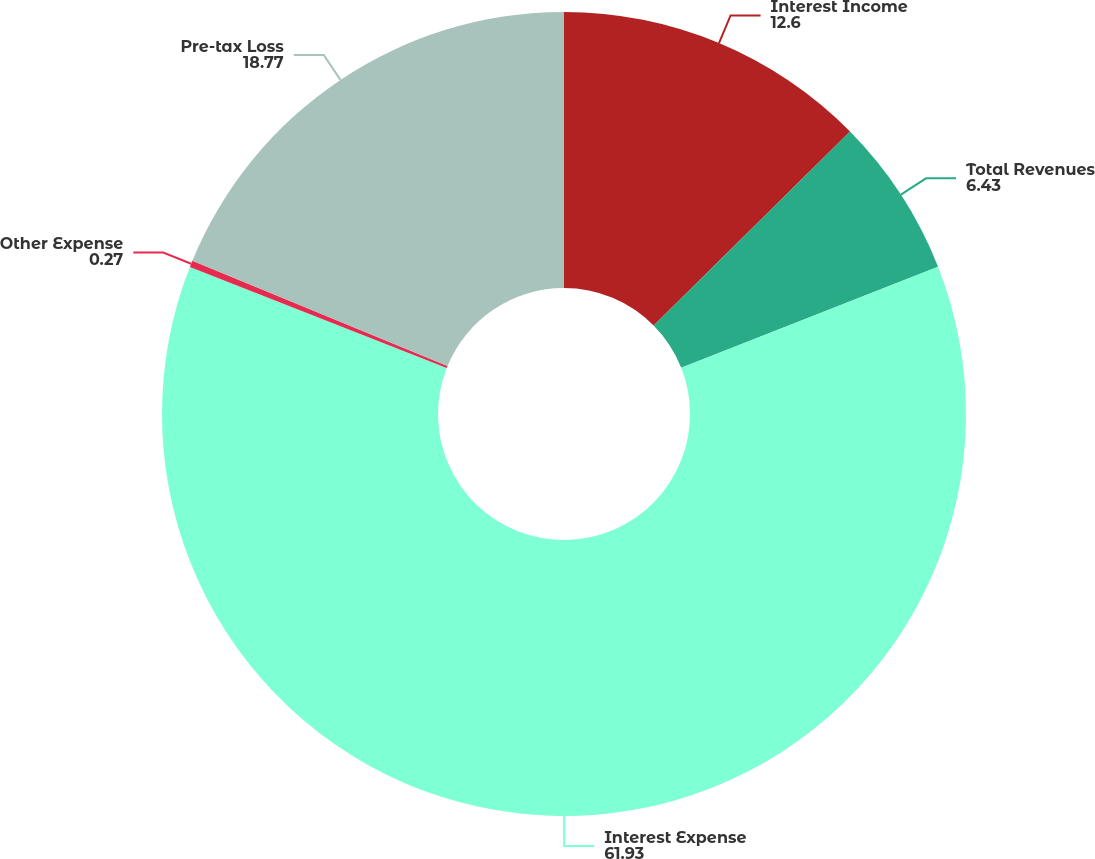<chart> <loc_0><loc_0><loc_500><loc_500><pie_chart><fcel>Interest Income<fcel>Total Revenues<fcel>Interest Expense<fcel>Other Expense<fcel>Pre-tax Loss<nl><fcel>12.6%<fcel>6.43%<fcel>61.93%<fcel>0.27%<fcel>18.77%<nl></chart> 